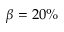<formula> <loc_0><loc_0><loc_500><loc_500>\beta = 2 0 \%</formula> 